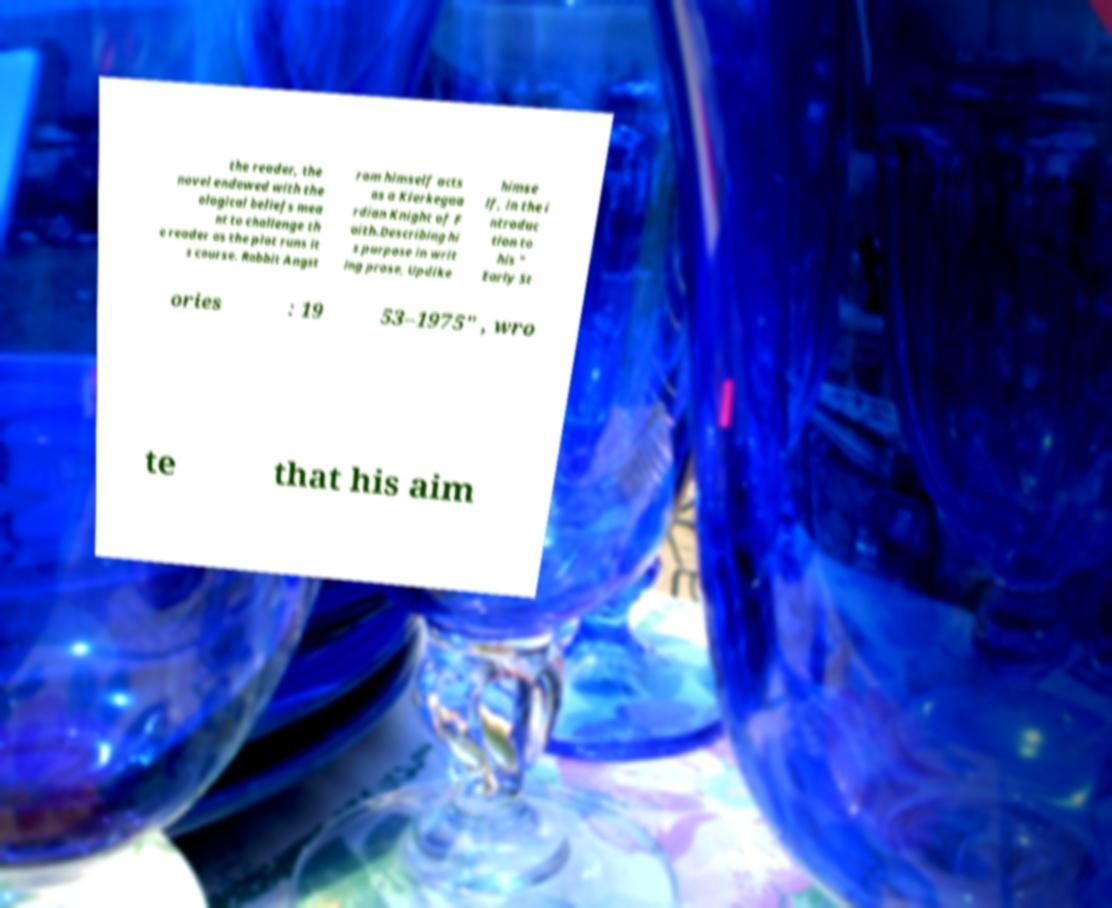For documentation purposes, I need the text within this image transcribed. Could you provide that? the reader, the novel endowed with the ological beliefs mea nt to challenge th e reader as the plot runs it s course. Rabbit Angst rom himself acts as a Kierkegaa rdian Knight of F aith.Describing hi s purpose in writ ing prose, Updike himse lf, in the i ntroduc tion to his " Early St ories : 19 53–1975" , wro te that his aim 